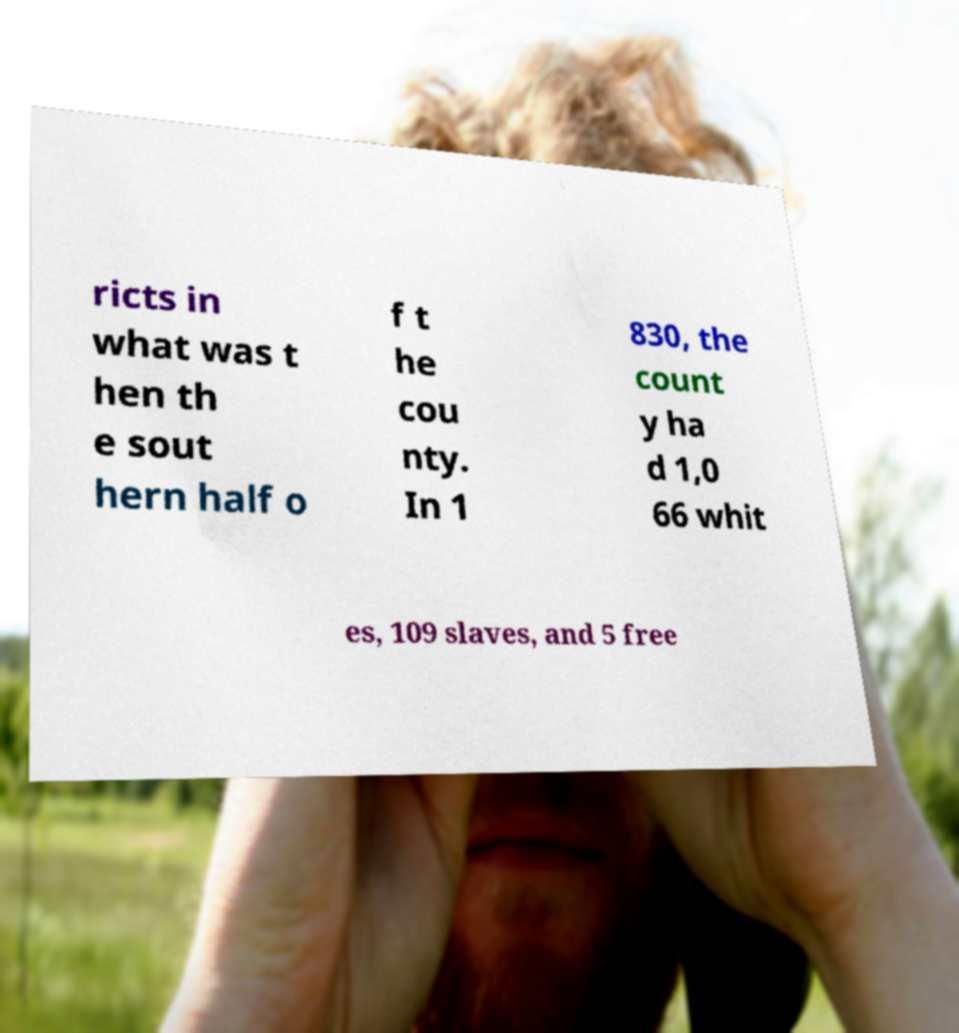For documentation purposes, I need the text within this image transcribed. Could you provide that? ricts in what was t hen th e sout hern half o f t he cou nty. In 1 830, the count y ha d 1,0 66 whit es, 109 slaves, and 5 free 